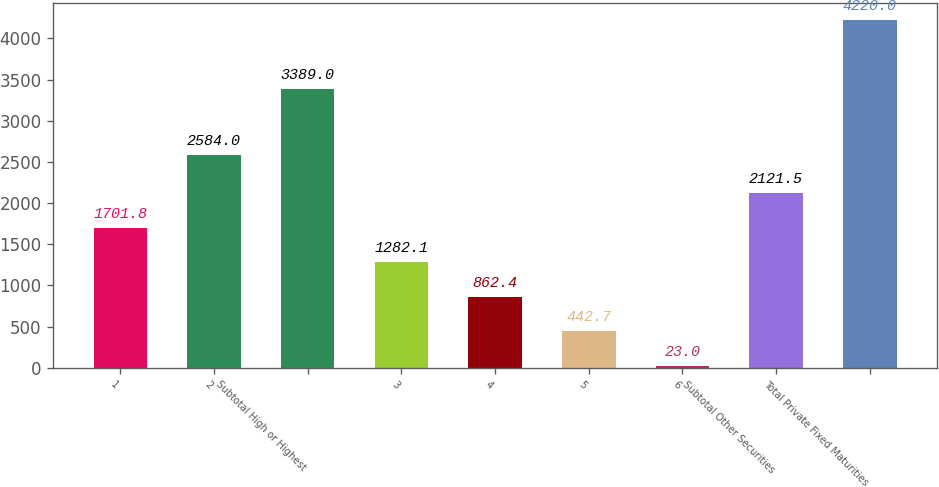Convert chart. <chart><loc_0><loc_0><loc_500><loc_500><bar_chart><fcel>1<fcel>2<fcel>Subtotal High or Highest<fcel>3<fcel>4<fcel>5<fcel>6<fcel>Subtotal Other Securities<fcel>Total Private Fixed Maturities<nl><fcel>1701.8<fcel>2584<fcel>3389<fcel>1282.1<fcel>862.4<fcel>442.7<fcel>23<fcel>2121.5<fcel>4220<nl></chart> 